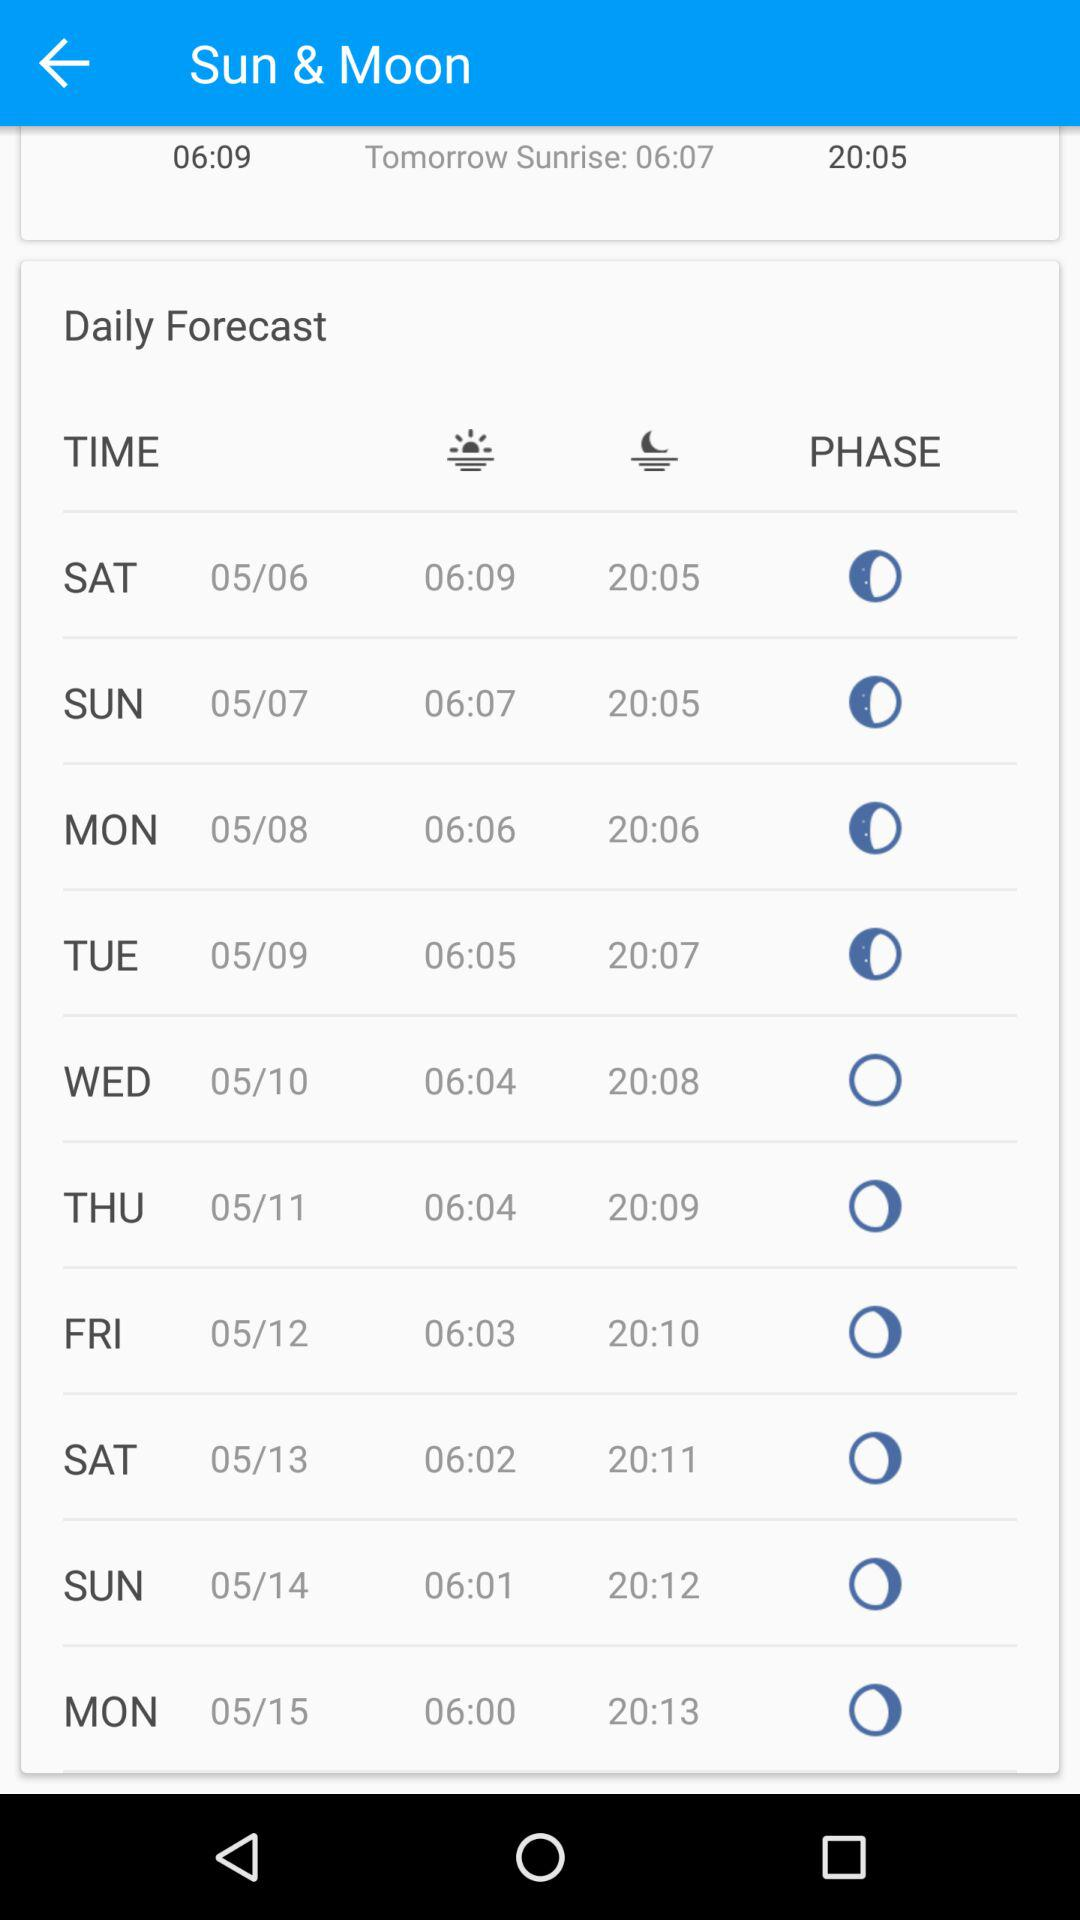What is the sunset time on Saturday, May 13? The sunset time on Saturday, May 13 is 20:11. 